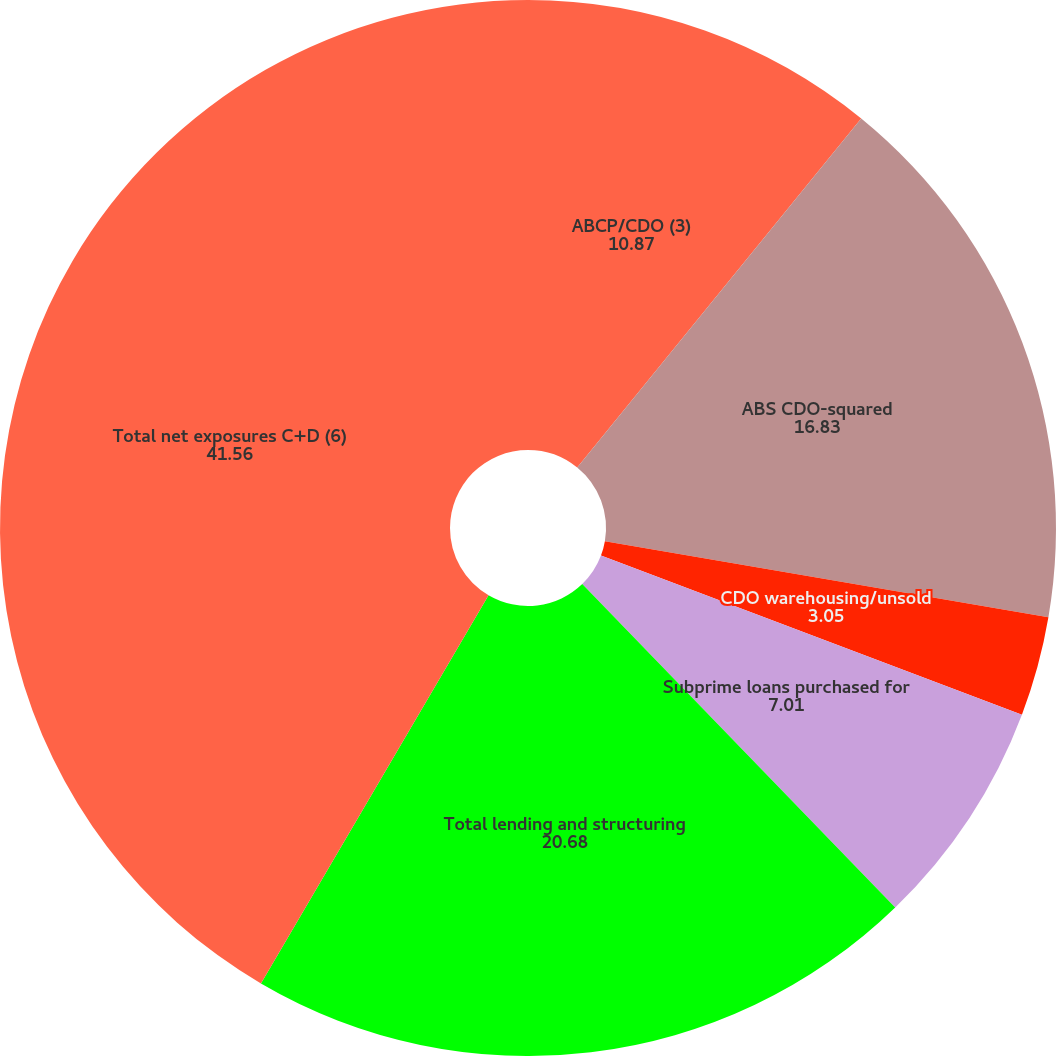Convert chart. <chart><loc_0><loc_0><loc_500><loc_500><pie_chart><fcel>ABCP/CDO (3)<fcel>ABS CDO-squared<fcel>CDO warehousing/unsold<fcel>Subprime loans purchased for<fcel>Total lending and structuring<fcel>Total net exposures C+D (6)<nl><fcel>10.87%<fcel>16.83%<fcel>3.05%<fcel>7.01%<fcel>20.68%<fcel>41.56%<nl></chart> 